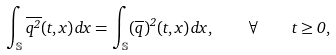Convert formula to latex. <formula><loc_0><loc_0><loc_500><loc_500>\int _ { \mathbb { S } } \overline { q ^ { 2 } } ( t , x ) \, d x = \int _ { \mathbb { S } } ( \overline { q } ) ^ { 2 } ( t , x ) \, d x , \quad \forall \quad t \geq 0 ,</formula> 